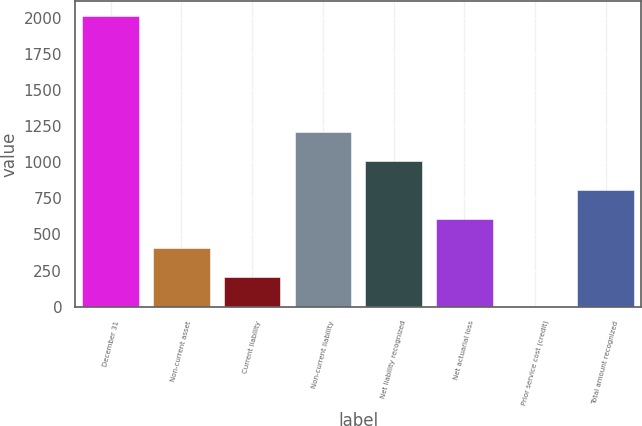Convert chart. <chart><loc_0><loc_0><loc_500><loc_500><bar_chart><fcel>December 31<fcel>Non-current asset<fcel>Current liability<fcel>Non-current liability<fcel>Net liability recognized<fcel>Net actuarial loss<fcel>Prior service cost (credit)<fcel>Total amount recognized<nl><fcel>2014<fcel>403.68<fcel>202.39<fcel>1208.84<fcel>1007.55<fcel>604.97<fcel>1.1<fcel>806.26<nl></chart> 